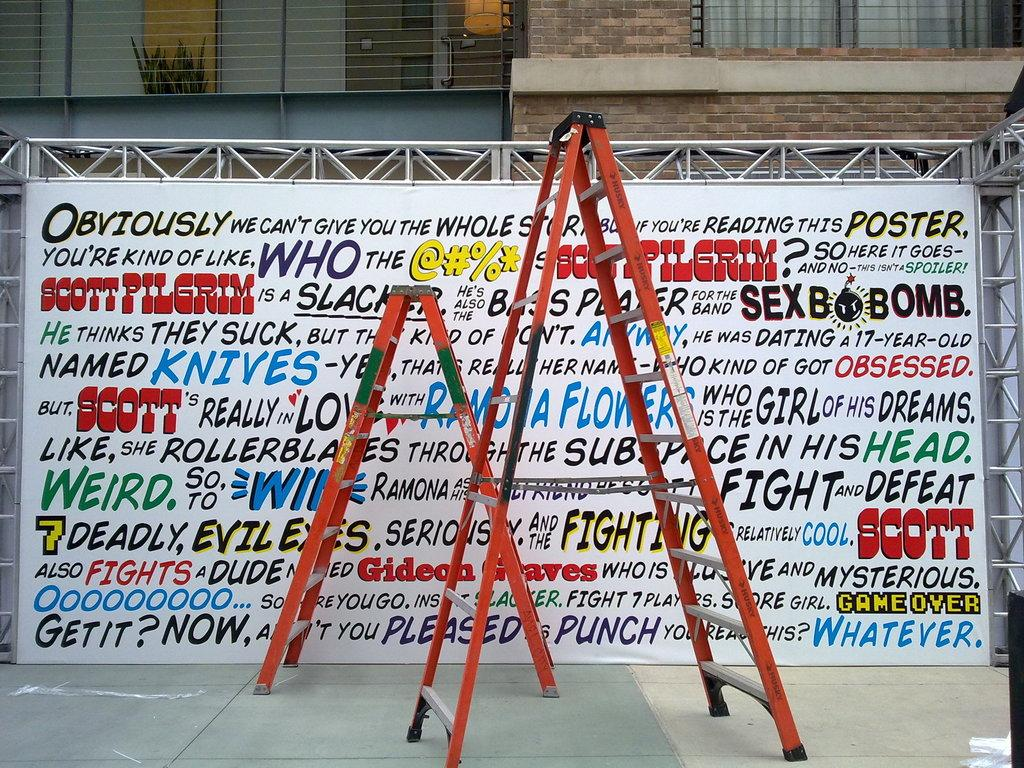<image>
Render a clear and concise summary of the photo. A sign with text in multiple different colors which shows 'Obviously' as the first word. 